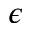Convert formula to latex. <formula><loc_0><loc_0><loc_500><loc_500>\epsilon</formula> 